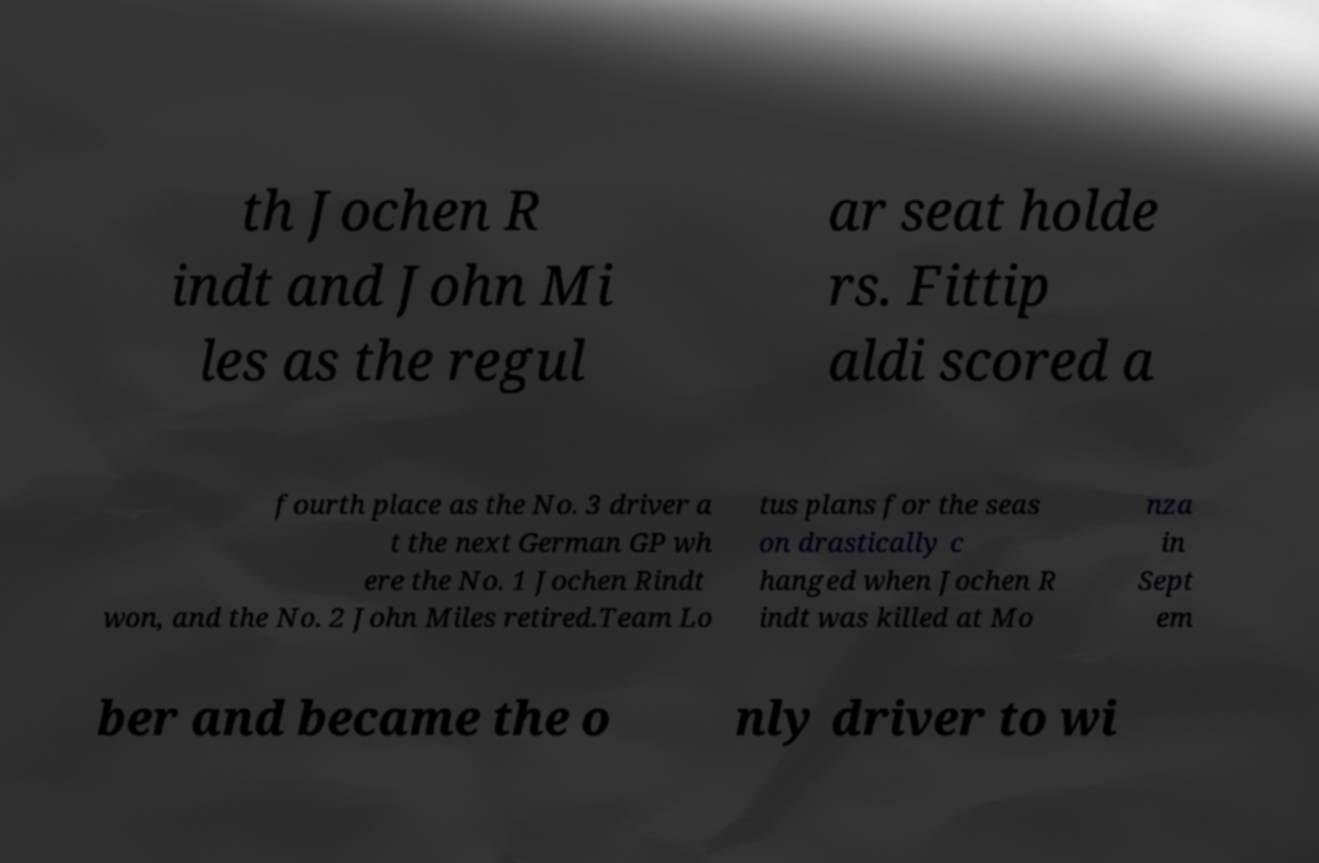For documentation purposes, I need the text within this image transcribed. Could you provide that? th Jochen R indt and John Mi les as the regul ar seat holde rs. Fittip aldi scored a fourth place as the No. 3 driver a t the next German GP wh ere the No. 1 Jochen Rindt won, and the No. 2 John Miles retired.Team Lo tus plans for the seas on drastically c hanged when Jochen R indt was killed at Mo nza in Sept em ber and became the o nly driver to wi 